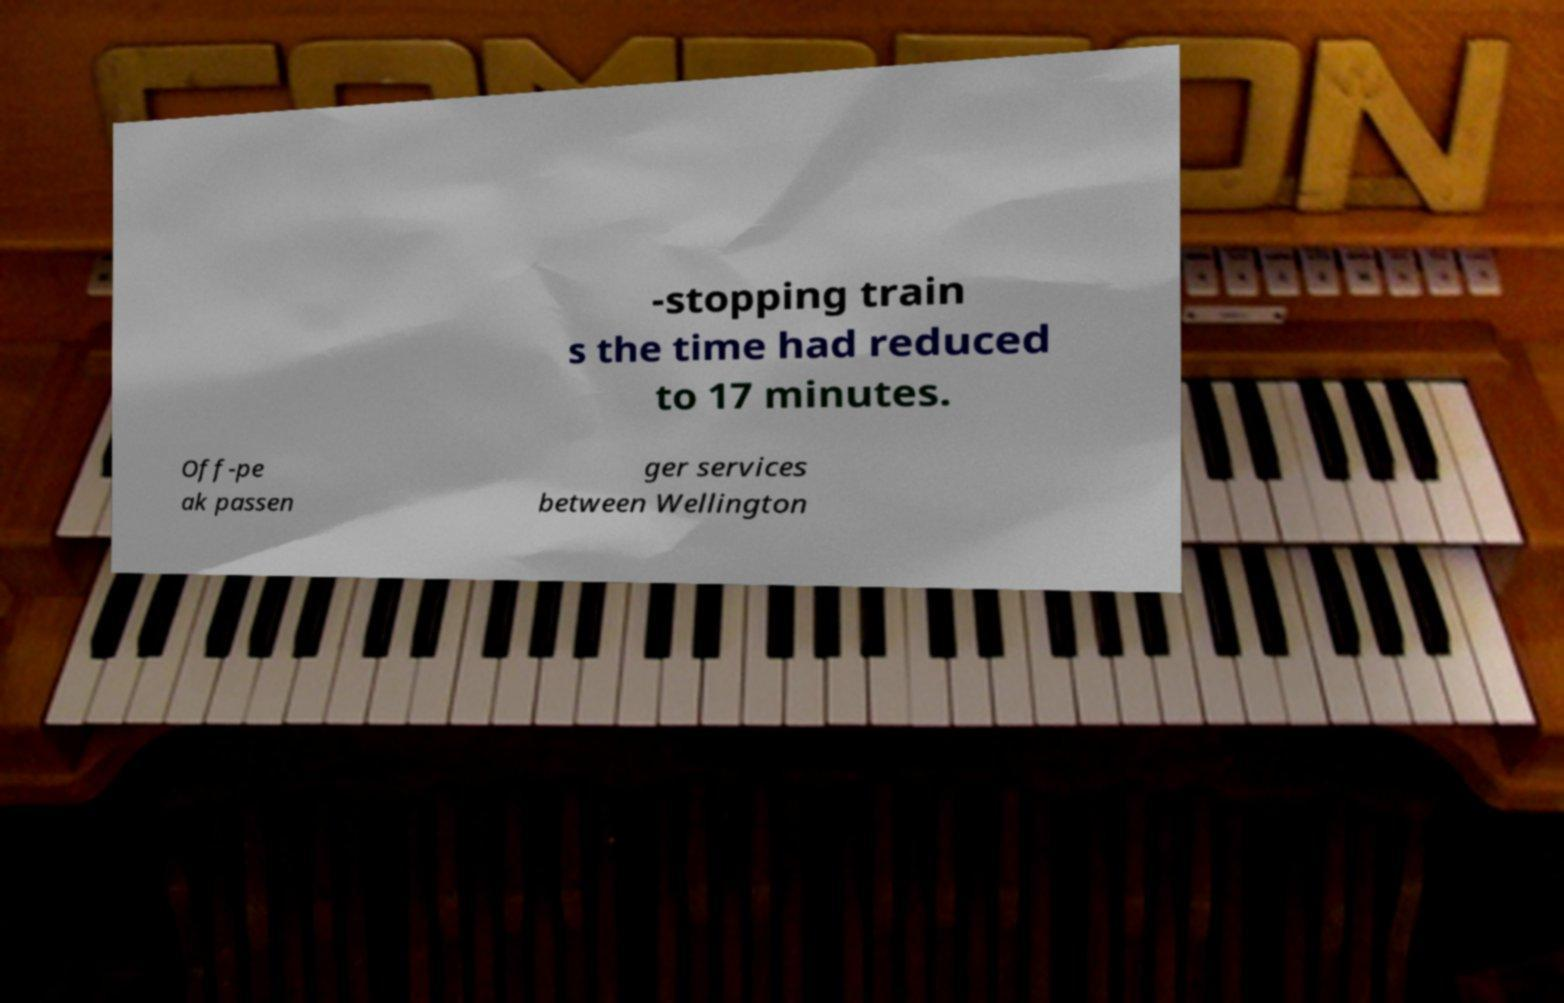There's text embedded in this image that I need extracted. Can you transcribe it verbatim? -stopping train s the time had reduced to 17 minutes. Off-pe ak passen ger services between Wellington 